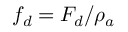Convert formula to latex. <formula><loc_0><loc_0><loc_500><loc_500>f _ { d } = F _ { d } / \rho _ { a }</formula> 